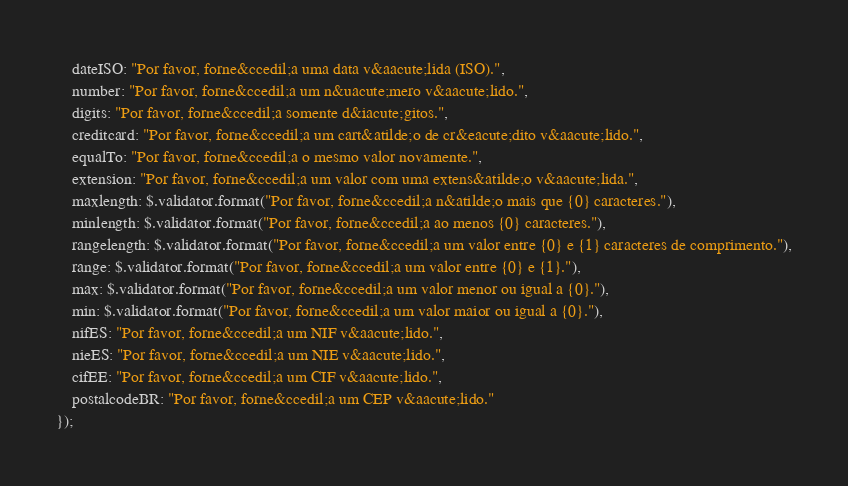Convert code to text. <code><loc_0><loc_0><loc_500><loc_500><_JavaScript_>    dateISO: "Por favor, forne&ccedil;a uma data v&aacute;lida (ISO).",
    number: "Por favor, forne&ccedil;a um n&uacute;mero v&aacute;lido.",
    digits: "Por favor, forne&ccedil;a somente d&iacute;gitos.",
    creditcard: "Por favor, forne&ccedil;a um cart&atilde;o de cr&eacute;dito v&aacute;lido.",
    equalTo: "Por favor, forne&ccedil;a o mesmo valor novamente.",
    extension: "Por favor, forne&ccedil;a um valor com uma extens&atilde;o v&aacute;lida.",
    maxlength: $.validator.format("Por favor, forne&ccedil;a n&atilde;o mais que {0} caracteres."),
    minlength: $.validator.format("Por favor, forne&ccedil;a ao menos {0} caracteres."),
    rangelength: $.validator.format("Por favor, forne&ccedil;a um valor entre {0} e {1} caracteres de comprimento."),
    range: $.validator.format("Por favor, forne&ccedil;a um valor entre {0} e {1}."),
    max: $.validator.format("Por favor, forne&ccedil;a um valor menor ou igual a {0}."),
    min: $.validator.format("Por favor, forne&ccedil;a um valor maior ou igual a {0}."),
    nifES: "Por favor, forne&ccedil;a um NIF v&aacute;lido.",
    nieES: "Por favor, forne&ccedil;a um NIE v&aacute;lido.",
    cifEE: "Por favor, forne&ccedil;a um CIF v&aacute;lido.",
    postalcodeBR: "Por favor, forne&ccedil;a um CEP v&aacute;lido."
});
</code> 